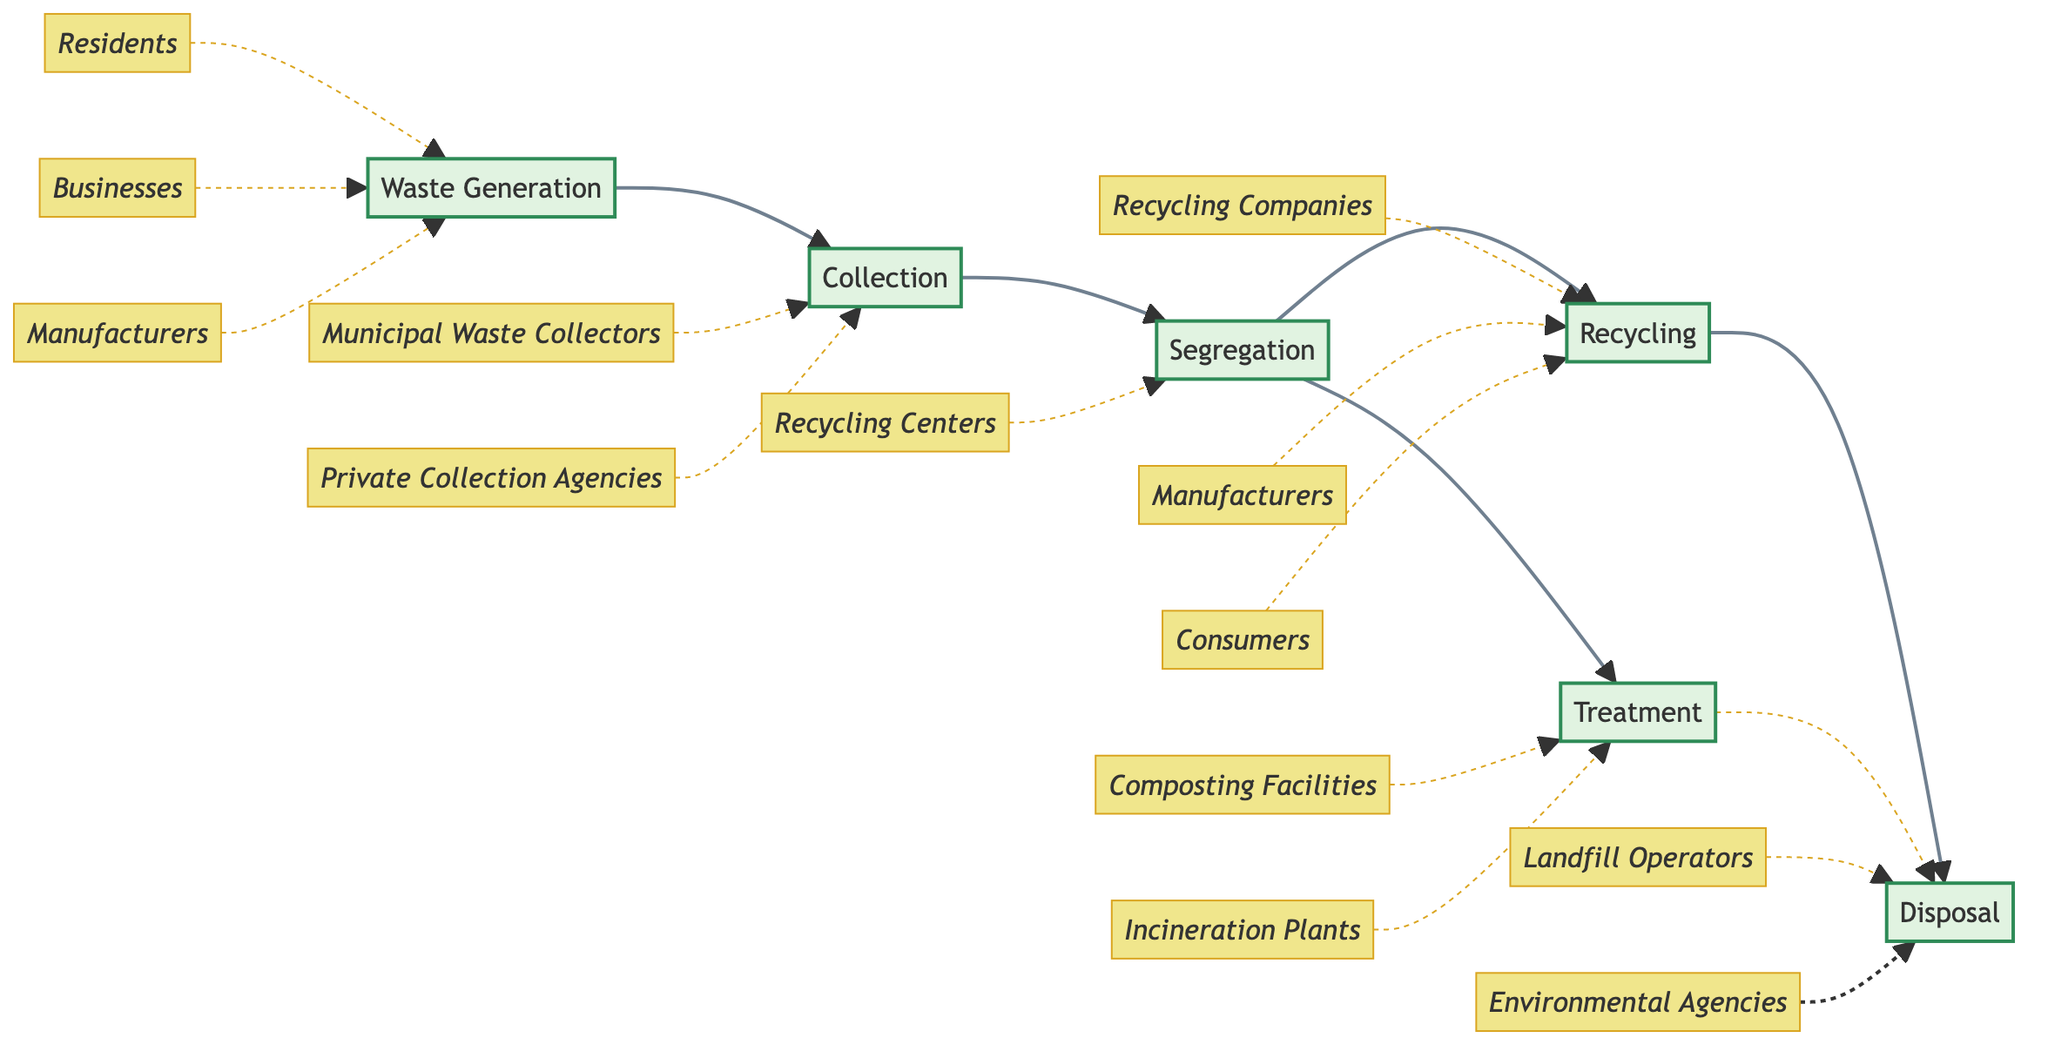What is the first step in the waste management strategy? The first step in the waste management strategy is depicted as 'Waste Generation', which is where the process begins, indicating the sources of waste.
Answer: Waste Generation How many primary processes are involved in the waste management strategy? By counting the main nodes in the flowchart, I find six processes: Waste Generation, Collection, Segregation, Recycling, Treatment, and Disposal.
Answer: Six Which stakeholders are associated with the Collection process? The diagram shows two stakeholders connected to the Collection process: Municipal Waste Collectors and Private Collection Agencies.
Answer: Municipal Waste Collectors, Private Collection Agencies What must happen after Segregation before waste is finally disposed of? After Segregation, the waste must either be sent to Recycling or Treatment, as indicated by the connections leading from the Segregation process.
Answer: Recycling or Treatment Which process directly leads to Disposal? The direct paths to Disposal come from both Recycling and Treatment processes, indicating that waste must be processed through either to end up at Disposal.
Answer: Recycling, Treatment What are the two treatment methods specified in the flowchart? The two treatment methods specified are composting organic waste and incinerating hazardous waste, which are indicated in the Treatment process.
Answer: Composting, Incineration Identify the stakeholders involved in the Recycling process. The diagram lists three stakeholders involved in the Recycling process: Recycling Companies, Manufacturers, and Consumers, each connected to that process.
Answer: Recycling Companies, Manufacturers, Consumers What type of waste do Composting Facilities manage according to the diagram? According to the diagram, Composting Facilities manage organic waste, as noted in the Treatment process.
Answer: Organic waste How do stakeholders influence the Waste Generation process? Stakeholders such as Residents, Businesses, and Manufacturers all contribute to Waste Generation, indicating their influence in producing waste at the source.
Answer: Residents, Businesses, Manufacturers 